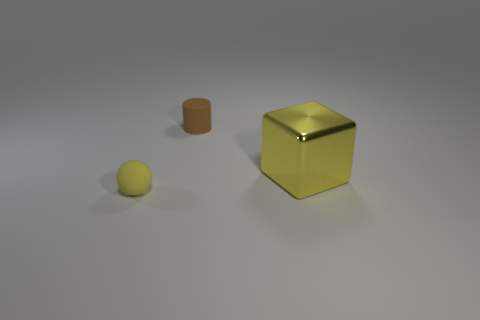If these objects were part of a larger group, what could the missing pieces be? If these objects were part of a set, additional items might include various geometric shapes of different sizes and colors. Perhaps they're part of a collection used for educational purposes, like teaching geometry or spatial reasoning, or they might simply be minimalist design elements in a modern decor scheme. 